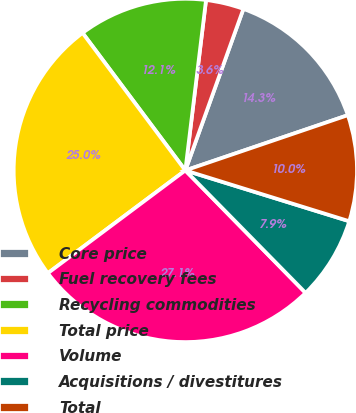Convert chart to OTSL. <chart><loc_0><loc_0><loc_500><loc_500><pie_chart><fcel>Core price<fcel>Fuel recovery fees<fcel>Recycling commodities<fcel>Total price<fcel>Volume<fcel>Acquisitions / divestitures<fcel>Total<nl><fcel>14.29%<fcel>3.57%<fcel>12.14%<fcel>25.0%<fcel>27.14%<fcel>7.86%<fcel>10.0%<nl></chart> 